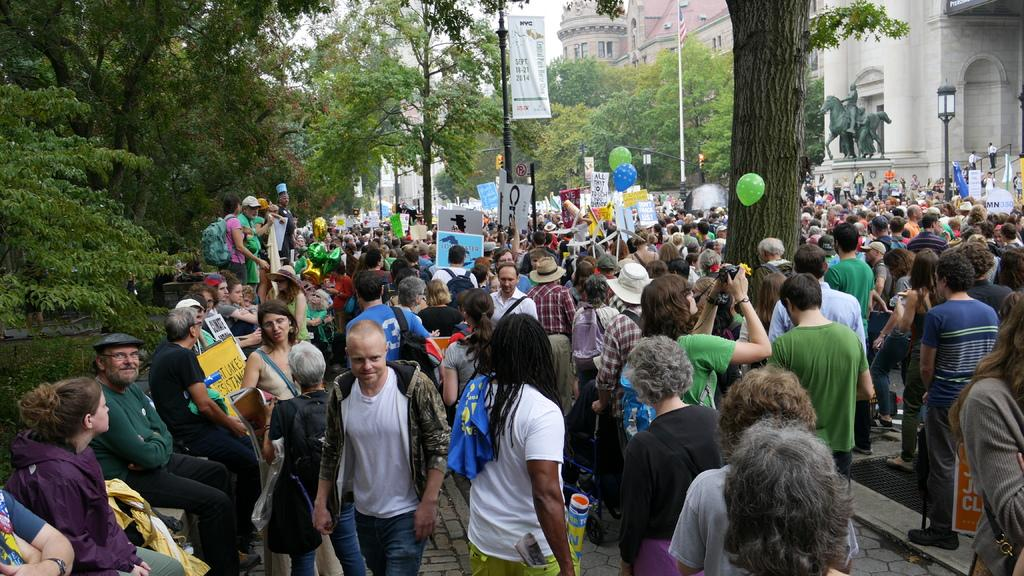What is located at the bottom of the image? There is a crowd at the bottom of the image. What can be seen in the image besides the crowd? There are balloons, boards, and poles in the image. What is visible in the background of the image? There are trees, buildings, a statue, and the sky visible in the background of the image. What type of goldfish can be seen swimming in the image? There are no goldfish present in the image. What type of order is being followed by the crowd in the image? The image does not provide information about any specific order being followed by the crowd. 